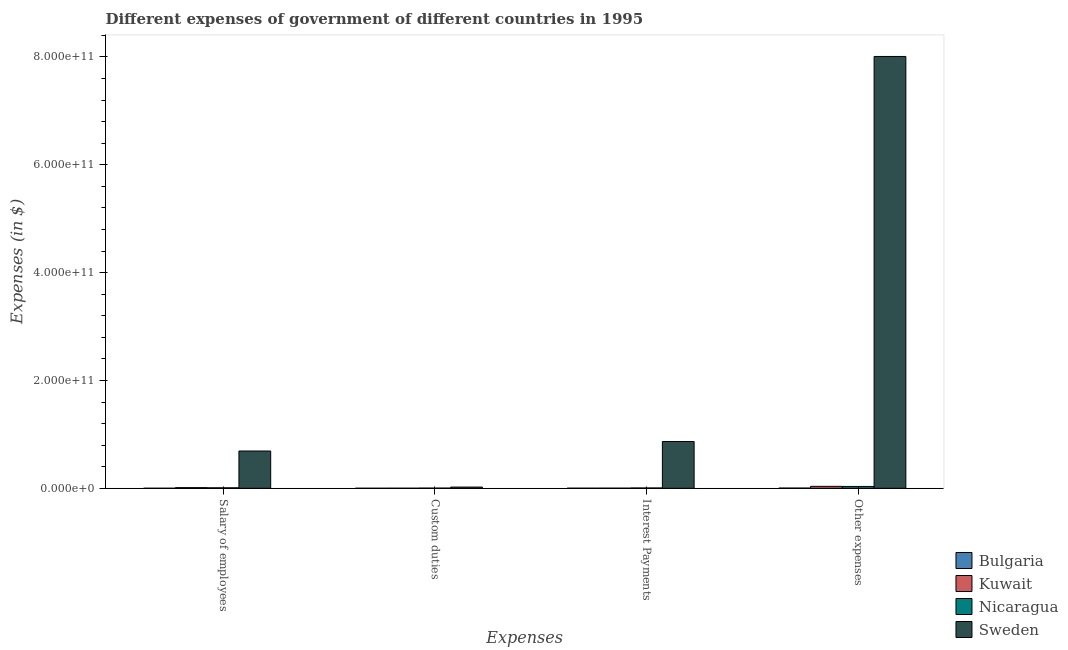How many different coloured bars are there?
Ensure brevity in your answer.  4. How many groups of bars are there?
Offer a terse response. 4. How many bars are there on the 3rd tick from the left?
Make the answer very short. 4. How many bars are there on the 3rd tick from the right?
Your answer should be compact. 4. What is the label of the 3rd group of bars from the left?
Provide a succinct answer. Interest Payments. What is the amount spent on interest payments in Kuwait?
Your response must be concise. 1.78e+08. Across all countries, what is the maximum amount spent on other expenses?
Ensure brevity in your answer.  8.01e+11. Across all countries, what is the minimum amount spent on salary of employees?
Your response must be concise. 2.34e+07. In which country was the amount spent on interest payments minimum?
Offer a very short reply. Bulgaria. What is the total amount spent on other expenses in the graph?
Give a very brief answer. 8.08e+11. What is the difference between the amount spent on interest payments in Bulgaria and that in Sweden?
Your answer should be very brief. -8.66e+1. What is the difference between the amount spent on salary of employees in Sweden and the amount spent on other expenses in Kuwait?
Ensure brevity in your answer.  6.56e+1. What is the average amount spent on interest payments per country?
Your answer should be compact. 2.19e+1. What is the difference between the amount spent on custom duties and amount spent on interest payments in Kuwait?
Give a very brief answer. -1.13e+08. What is the ratio of the amount spent on salary of employees in Sweden to that in Kuwait?
Give a very brief answer. 59.19. Is the amount spent on custom duties in Kuwait less than that in Nicaragua?
Offer a terse response. Yes. What is the difference between the highest and the second highest amount spent on salary of employees?
Offer a very short reply. 6.80e+1. What is the difference between the highest and the lowest amount spent on custom duties?
Make the answer very short. 2.20e+09. Is the sum of the amount spent on salary of employees in Bulgaria and Sweden greater than the maximum amount spent on interest payments across all countries?
Keep it short and to the point. No. Is it the case that in every country, the sum of the amount spent on other expenses and amount spent on interest payments is greater than the sum of amount spent on custom duties and amount spent on salary of employees?
Your answer should be very brief. No. What does the 1st bar from the left in Other expenses represents?
Offer a very short reply. Bulgaria. What does the 2nd bar from the right in Salary of employees represents?
Give a very brief answer. Nicaragua. How many bars are there?
Provide a short and direct response. 16. Are all the bars in the graph horizontal?
Your answer should be very brief. No. How many countries are there in the graph?
Ensure brevity in your answer.  4. What is the difference between two consecutive major ticks on the Y-axis?
Your answer should be compact. 2.00e+11. Are the values on the major ticks of Y-axis written in scientific E-notation?
Ensure brevity in your answer.  Yes. Does the graph contain any zero values?
Give a very brief answer. No. Where does the legend appear in the graph?
Offer a very short reply. Bottom right. What is the title of the graph?
Your response must be concise. Different expenses of government of different countries in 1995. What is the label or title of the X-axis?
Provide a short and direct response. Expenses. What is the label or title of the Y-axis?
Offer a terse response. Expenses (in $). What is the Expenses (in $) of Bulgaria in Salary of employees?
Offer a very short reply. 2.34e+07. What is the Expenses (in $) of Kuwait in Salary of employees?
Offer a very short reply. 1.17e+09. What is the Expenses (in $) in Nicaragua in Salary of employees?
Offer a very short reply. 8.64e+08. What is the Expenses (in $) in Sweden in Salary of employees?
Make the answer very short. 6.91e+1. What is the Expenses (in $) of Bulgaria in Custom duties?
Provide a succinct answer. 1.95e+07. What is the Expenses (in $) of Kuwait in Custom duties?
Provide a short and direct response. 6.50e+07. What is the Expenses (in $) in Nicaragua in Custom duties?
Your answer should be compact. 3.11e+08. What is the Expenses (in $) in Sweden in Custom duties?
Make the answer very short. 2.22e+09. What is the Expenses (in $) in Bulgaria in Interest Payments?
Your response must be concise. 1.29e+08. What is the Expenses (in $) of Kuwait in Interest Payments?
Your answer should be compact. 1.78e+08. What is the Expenses (in $) of Nicaragua in Interest Payments?
Provide a succinct answer. 5.71e+08. What is the Expenses (in $) of Sweden in Interest Payments?
Offer a very short reply. 8.68e+1. What is the Expenses (in $) in Bulgaria in Other expenses?
Keep it short and to the point. 3.47e+08. What is the Expenses (in $) in Kuwait in Other expenses?
Ensure brevity in your answer.  3.57e+09. What is the Expenses (in $) of Nicaragua in Other expenses?
Offer a very short reply. 3.41e+09. What is the Expenses (in $) in Sweden in Other expenses?
Your response must be concise. 8.01e+11. Across all Expenses, what is the maximum Expenses (in $) in Bulgaria?
Provide a succinct answer. 3.47e+08. Across all Expenses, what is the maximum Expenses (in $) of Kuwait?
Keep it short and to the point. 3.57e+09. Across all Expenses, what is the maximum Expenses (in $) of Nicaragua?
Provide a succinct answer. 3.41e+09. Across all Expenses, what is the maximum Expenses (in $) of Sweden?
Give a very brief answer. 8.01e+11. Across all Expenses, what is the minimum Expenses (in $) in Bulgaria?
Provide a succinct answer. 1.95e+07. Across all Expenses, what is the minimum Expenses (in $) in Kuwait?
Offer a terse response. 6.50e+07. Across all Expenses, what is the minimum Expenses (in $) of Nicaragua?
Your response must be concise. 3.11e+08. Across all Expenses, what is the minimum Expenses (in $) in Sweden?
Give a very brief answer. 2.22e+09. What is the total Expenses (in $) of Bulgaria in the graph?
Make the answer very short. 5.19e+08. What is the total Expenses (in $) in Kuwait in the graph?
Your answer should be very brief. 4.98e+09. What is the total Expenses (in $) in Nicaragua in the graph?
Keep it short and to the point. 5.15e+09. What is the total Expenses (in $) of Sweden in the graph?
Keep it short and to the point. 9.59e+11. What is the difference between the Expenses (in $) of Bulgaria in Salary of employees and that in Custom duties?
Ensure brevity in your answer.  3.91e+06. What is the difference between the Expenses (in $) of Kuwait in Salary of employees and that in Custom duties?
Provide a succinct answer. 1.10e+09. What is the difference between the Expenses (in $) of Nicaragua in Salary of employees and that in Custom duties?
Your answer should be compact. 5.53e+08. What is the difference between the Expenses (in $) of Sweden in Salary of employees and that in Custom duties?
Your response must be concise. 6.69e+1. What is the difference between the Expenses (in $) of Bulgaria in Salary of employees and that in Interest Payments?
Your response must be concise. -1.05e+08. What is the difference between the Expenses (in $) of Kuwait in Salary of employees and that in Interest Payments?
Provide a succinct answer. 9.90e+08. What is the difference between the Expenses (in $) in Nicaragua in Salary of employees and that in Interest Payments?
Your response must be concise. 2.93e+08. What is the difference between the Expenses (in $) in Sweden in Salary of employees and that in Interest Payments?
Provide a succinct answer. -1.76e+1. What is the difference between the Expenses (in $) in Bulgaria in Salary of employees and that in Other expenses?
Your answer should be compact. -3.24e+08. What is the difference between the Expenses (in $) in Kuwait in Salary of employees and that in Other expenses?
Provide a short and direct response. -2.40e+09. What is the difference between the Expenses (in $) of Nicaragua in Salary of employees and that in Other expenses?
Offer a very short reply. -2.54e+09. What is the difference between the Expenses (in $) in Sweden in Salary of employees and that in Other expenses?
Your answer should be very brief. -7.32e+11. What is the difference between the Expenses (in $) in Bulgaria in Custom duties and that in Interest Payments?
Your answer should be compact. -1.09e+08. What is the difference between the Expenses (in $) of Kuwait in Custom duties and that in Interest Payments?
Keep it short and to the point. -1.13e+08. What is the difference between the Expenses (in $) of Nicaragua in Custom duties and that in Interest Payments?
Ensure brevity in your answer.  -2.60e+08. What is the difference between the Expenses (in $) in Sweden in Custom duties and that in Interest Payments?
Your answer should be very brief. -8.46e+1. What is the difference between the Expenses (in $) in Bulgaria in Custom duties and that in Other expenses?
Give a very brief answer. -3.28e+08. What is the difference between the Expenses (in $) of Kuwait in Custom duties and that in Other expenses?
Provide a succinct answer. -3.51e+09. What is the difference between the Expenses (in $) of Nicaragua in Custom duties and that in Other expenses?
Ensure brevity in your answer.  -3.09e+09. What is the difference between the Expenses (in $) of Sweden in Custom duties and that in Other expenses?
Keep it short and to the point. -7.99e+11. What is the difference between the Expenses (in $) of Bulgaria in Interest Payments and that in Other expenses?
Provide a succinct answer. -2.18e+08. What is the difference between the Expenses (in $) in Kuwait in Interest Payments and that in Other expenses?
Make the answer very short. -3.40e+09. What is the difference between the Expenses (in $) of Nicaragua in Interest Payments and that in Other expenses?
Your response must be concise. -2.83e+09. What is the difference between the Expenses (in $) in Sweden in Interest Payments and that in Other expenses?
Your answer should be compact. -7.14e+11. What is the difference between the Expenses (in $) of Bulgaria in Salary of employees and the Expenses (in $) of Kuwait in Custom duties?
Your response must be concise. -4.16e+07. What is the difference between the Expenses (in $) of Bulgaria in Salary of employees and the Expenses (in $) of Nicaragua in Custom duties?
Make the answer very short. -2.88e+08. What is the difference between the Expenses (in $) of Bulgaria in Salary of employees and the Expenses (in $) of Sweden in Custom duties?
Your answer should be very brief. -2.20e+09. What is the difference between the Expenses (in $) of Kuwait in Salary of employees and the Expenses (in $) of Nicaragua in Custom duties?
Provide a succinct answer. 8.57e+08. What is the difference between the Expenses (in $) of Kuwait in Salary of employees and the Expenses (in $) of Sweden in Custom duties?
Provide a succinct answer. -1.05e+09. What is the difference between the Expenses (in $) of Nicaragua in Salary of employees and the Expenses (in $) of Sweden in Custom duties?
Keep it short and to the point. -1.36e+09. What is the difference between the Expenses (in $) of Bulgaria in Salary of employees and the Expenses (in $) of Kuwait in Interest Payments?
Your answer should be compact. -1.55e+08. What is the difference between the Expenses (in $) in Bulgaria in Salary of employees and the Expenses (in $) in Nicaragua in Interest Payments?
Keep it short and to the point. -5.47e+08. What is the difference between the Expenses (in $) in Bulgaria in Salary of employees and the Expenses (in $) in Sweden in Interest Payments?
Keep it short and to the point. -8.67e+1. What is the difference between the Expenses (in $) in Kuwait in Salary of employees and the Expenses (in $) in Nicaragua in Interest Payments?
Your response must be concise. 5.97e+08. What is the difference between the Expenses (in $) in Kuwait in Salary of employees and the Expenses (in $) in Sweden in Interest Payments?
Keep it short and to the point. -8.56e+1. What is the difference between the Expenses (in $) of Nicaragua in Salary of employees and the Expenses (in $) of Sweden in Interest Payments?
Offer a very short reply. -8.59e+1. What is the difference between the Expenses (in $) of Bulgaria in Salary of employees and the Expenses (in $) of Kuwait in Other expenses?
Keep it short and to the point. -3.55e+09. What is the difference between the Expenses (in $) of Bulgaria in Salary of employees and the Expenses (in $) of Nicaragua in Other expenses?
Offer a very short reply. -3.38e+09. What is the difference between the Expenses (in $) in Bulgaria in Salary of employees and the Expenses (in $) in Sweden in Other expenses?
Make the answer very short. -8.01e+11. What is the difference between the Expenses (in $) in Kuwait in Salary of employees and the Expenses (in $) in Nicaragua in Other expenses?
Provide a succinct answer. -2.24e+09. What is the difference between the Expenses (in $) of Kuwait in Salary of employees and the Expenses (in $) of Sweden in Other expenses?
Offer a terse response. -8.00e+11. What is the difference between the Expenses (in $) in Nicaragua in Salary of employees and the Expenses (in $) in Sweden in Other expenses?
Give a very brief answer. -8.00e+11. What is the difference between the Expenses (in $) of Bulgaria in Custom duties and the Expenses (in $) of Kuwait in Interest Payments?
Your response must be concise. -1.59e+08. What is the difference between the Expenses (in $) of Bulgaria in Custom duties and the Expenses (in $) of Nicaragua in Interest Payments?
Offer a very short reply. -5.51e+08. What is the difference between the Expenses (in $) in Bulgaria in Custom duties and the Expenses (in $) in Sweden in Interest Payments?
Your response must be concise. -8.68e+1. What is the difference between the Expenses (in $) of Kuwait in Custom duties and the Expenses (in $) of Nicaragua in Interest Payments?
Offer a terse response. -5.06e+08. What is the difference between the Expenses (in $) in Kuwait in Custom duties and the Expenses (in $) in Sweden in Interest Payments?
Give a very brief answer. -8.67e+1. What is the difference between the Expenses (in $) in Nicaragua in Custom duties and the Expenses (in $) in Sweden in Interest Payments?
Your answer should be compact. -8.65e+1. What is the difference between the Expenses (in $) in Bulgaria in Custom duties and the Expenses (in $) in Kuwait in Other expenses?
Ensure brevity in your answer.  -3.55e+09. What is the difference between the Expenses (in $) in Bulgaria in Custom duties and the Expenses (in $) in Nicaragua in Other expenses?
Provide a succinct answer. -3.39e+09. What is the difference between the Expenses (in $) in Bulgaria in Custom duties and the Expenses (in $) in Sweden in Other expenses?
Keep it short and to the point. -8.01e+11. What is the difference between the Expenses (in $) in Kuwait in Custom duties and the Expenses (in $) in Nicaragua in Other expenses?
Provide a short and direct response. -3.34e+09. What is the difference between the Expenses (in $) in Kuwait in Custom duties and the Expenses (in $) in Sweden in Other expenses?
Ensure brevity in your answer.  -8.01e+11. What is the difference between the Expenses (in $) of Nicaragua in Custom duties and the Expenses (in $) of Sweden in Other expenses?
Offer a terse response. -8.01e+11. What is the difference between the Expenses (in $) of Bulgaria in Interest Payments and the Expenses (in $) of Kuwait in Other expenses?
Offer a very short reply. -3.44e+09. What is the difference between the Expenses (in $) in Bulgaria in Interest Payments and the Expenses (in $) in Nicaragua in Other expenses?
Your answer should be very brief. -3.28e+09. What is the difference between the Expenses (in $) in Bulgaria in Interest Payments and the Expenses (in $) in Sweden in Other expenses?
Give a very brief answer. -8.01e+11. What is the difference between the Expenses (in $) of Kuwait in Interest Payments and the Expenses (in $) of Nicaragua in Other expenses?
Keep it short and to the point. -3.23e+09. What is the difference between the Expenses (in $) in Kuwait in Interest Payments and the Expenses (in $) in Sweden in Other expenses?
Keep it short and to the point. -8.01e+11. What is the difference between the Expenses (in $) of Nicaragua in Interest Payments and the Expenses (in $) of Sweden in Other expenses?
Your answer should be very brief. -8.00e+11. What is the average Expenses (in $) in Bulgaria per Expenses?
Ensure brevity in your answer.  1.30e+08. What is the average Expenses (in $) of Kuwait per Expenses?
Offer a terse response. 1.25e+09. What is the average Expenses (in $) of Nicaragua per Expenses?
Offer a very short reply. 1.29e+09. What is the average Expenses (in $) of Sweden per Expenses?
Offer a terse response. 2.40e+11. What is the difference between the Expenses (in $) in Bulgaria and Expenses (in $) in Kuwait in Salary of employees?
Keep it short and to the point. -1.14e+09. What is the difference between the Expenses (in $) in Bulgaria and Expenses (in $) in Nicaragua in Salary of employees?
Your response must be concise. -8.40e+08. What is the difference between the Expenses (in $) in Bulgaria and Expenses (in $) in Sweden in Salary of employees?
Provide a succinct answer. -6.91e+1. What is the difference between the Expenses (in $) of Kuwait and Expenses (in $) of Nicaragua in Salary of employees?
Your answer should be very brief. 3.04e+08. What is the difference between the Expenses (in $) in Kuwait and Expenses (in $) in Sweden in Salary of employees?
Your answer should be compact. -6.80e+1. What is the difference between the Expenses (in $) in Nicaragua and Expenses (in $) in Sweden in Salary of employees?
Your response must be concise. -6.83e+1. What is the difference between the Expenses (in $) of Bulgaria and Expenses (in $) of Kuwait in Custom duties?
Offer a terse response. -4.55e+07. What is the difference between the Expenses (in $) of Bulgaria and Expenses (in $) of Nicaragua in Custom duties?
Provide a succinct answer. -2.92e+08. What is the difference between the Expenses (in $) of Bulgaria and Expenses (in $) of Sweden in Custom duties?
Your answer should be compact. -2.20e+09. What is the difference between the Expenses (in $) of Kuwait and Expenses (in $) of Nicaragua in Custom duties?
Make the answer very short. -2.46e+08. What is the difference between the Expenses (in $) of Kuwait and Expenses (in $) of Sweden in Custom duties?
Provide a succinct answer. -2.16e+09. What is the difference between the Expenses (in $) of Nicaragua and Expenses (in $) of Sweden in Custom duties?
Your answer should be very brief. -1.91e+09. What is the difference between the Expenses (in $) in Bulgaria and Expenses (in $) in Kuwait in Interest Payments?
Provide a succinct answer. -4.93e+07. What is the difference between the Expenses (in $) in Bulgaria and Expenses (in $) in Nicaragua in Interest Payments?
Your answer should be compact. -4.42e+08. What is the difference between the Expenses (in $) of Bulgaria and Expenses (in $) of Sweden in Interest Payments?
Make the answer very short. -8.66e+1. What is the difference between the Expenses (in $) of Kuwait and Expenses (in $) of Nicaragua in Interest Payments?
Your answer should be compact. -3.93e+08. What is the difference between the Expenses (in $) in Kuwait and Expenses (in $) in Sweden in Interest Payments?
Offer a very short reply. -8.66e+1. What is the difference between the Expenses (in $) in Nicaragua and Expenses (in $) in Sweden in Interest Payments?
Provide a short and direct response. -8.62e+1. What is the difference between the Expenses (in $) of Bulgaria and Expenses (in $) of Kuwait in Other expenses?
Your answer should be compact. -3.23e+09. What is the difference between the Expenses (in $) of Bulgaria and Expenses (in $) of Nicaragua in Other expenses?
Your answer should be very brief. -3.06e+09. What is the difference between the Expenses (in $) in Bulgaria and Expenses (in $) in Sweden in Other expenses?
Ensure brevity in your answer.  -8.01e+11. What is the difference between the Expenses (in $) of Kuwait and Expenses (in $) of Nicaragua in Other expenses?
Give a very brief answer. 1.68e+08. What is the difference between the Expenses (in $) in Kuwait and Expenses (in $) in Sweden in Other expenses?
Make the answer very short. -7.97e+11. What is the difference between the Expenses (in $) of Nicaragua and Expenses (in $) of Sweden in Other expenses?
Your answer should be very brief. -7.97e+11. What is the ratio of the Expenses (in $) in Bulgaria in Salary of employees to that in Custom duties?
Offer a very short reply. 1.2. What is the ratio of the Expenses (in $) in Kuwait in Salary of employees to that in Custom duties?
Provide a short and direct response. 17.97. What is the ratio of the Expenses (in $) in Nicaragua in Salary of employees to that in Custom duties?
Make the answer very short. 2.78. What is the ratio of the Expenses (in $) in Sweden in Salary of employees to that in Custom duties?
Your answer should be very brief. 31.14. What is the ratio of the Expenses (in $) in Bulgaria in Salary of employees to that in Interest Payments?
Your answer should be compact. 0.18. What is the ratio of the Expenses (in $) of Kuwait in Salary of employees to that in Interest Payments?
Offer a terse response. 6.56. What is the ratio of the Expenses (in $) of Nicaragua in Salary of employees to that in Interest Payments?
Your answer should be very brief. 1.51. What is the ratio of the Expenses (in $) of Sweden in Salary of employees to that in Interest Payments?
Your answer should be very brief. 0.8. What is the ratio of the Expenses (in $) in Bulgaria in Salary of employees to that in Other expenses?
Your response must be concise. 0.07. What is the ratio of the Expenses (in $) in Kuwait in Salary of employees to that in Other expenses?
Your answer should be very brief. 0.33. What is the ratio of the Expenses (in $) in Nicaragua in Salary of employees to that in Other expenses?
Make the answer very short. 0.25. What is the ratio of the Expenses (in $) of Sweden in Salary of employees to that in Other expenses?
Make the answer very short. 0.09. What is the ratio of the Expenses (in $) in Bulgaria in Custom duties to that in Interest Payments?
Offer a terse response. 0.15. What is the ratio of the Expenses (in $) of Kuwait in Custom duties to that in Interest Payments?
Provide a short and direct response. 0.37. What is the ratio of the Expenses (in $) of Nicaragua in Custom duties to that in Interest Payments?
Offer a terse response. 0.54. What is the ratio of the Expenses (in $) in Sweden in Custom duties to that in Interest Payments?
Give a very brief answer. 0.03. What is the ratio of the Expenses (in $) in Bulgaria in Custom duties to that in Other expenses?
Your response must be concise. 0.06. What is the ratio of the Expenses (in $) of Kuwait in Custom duties to that in Other expenses?
Ensure brevity in your answer.  0.02. What is the ratio of the Expenses (in $) of Nicaragua in Custom duties to that in Other expenses?
Make the answer very short. 0.09. What is the ratio of the Expenses (in $) in Sweden in Custom duties to that in Other expenses?
Your answer should be compact. 0. What is the ratio of the Expenses (in $) of Bulgaria in Interest Payments to that in Other expenses?
Provide a succinct answer. 0.37. What is the ratio of the Expenses (in $) of Kuwait in Interest Payments to that in Other expenses?
Make the answer very short. 0.05. What is the ratio of the Expenses (in $) of Nicaragua in Interest Payments to that in Other expenses?
Keep it short and to the point. 0.17. What is the ratio of the Expenses (in $) of Sweden in Interest Payments to that in Other expenses?
Your response must be concise. 0.11. What is the difference between the highest and the second highest Expenses (in $) in Bulgaria?
Provide a short and direct response. 2.18e+08. What is the difference between the highest and the second highest Expenses (in $) in Kuwait?
Your answer should be compact. 2.40e+09. What is the difference between the highest and the second highest Expenses (in $) of Nicaragua?
Provide a succinct answer. 2.54e+09. What is the difference between the highest and the second highest Expenses (in $) of Sweden?
Provide a short and direct response. 7.14e+11. What is the difference between the highest and the lowest Expenses (in $) in Bulgaria?
Your response must be concise. 3.28e+08. What is the difference between the highest and the lowest Expenses (in $) of Kuwait?
Provide a succinct answer. 3.51e+09. What is the difference between the highest and the lowest Expenses (in $) of Nicaragua?
Offer a terse response. 3.09e+09. What is the difference between the highest and the lowest Expenses (in $) of Sweden?
Keep it short and to the point. 7.99e+11. 